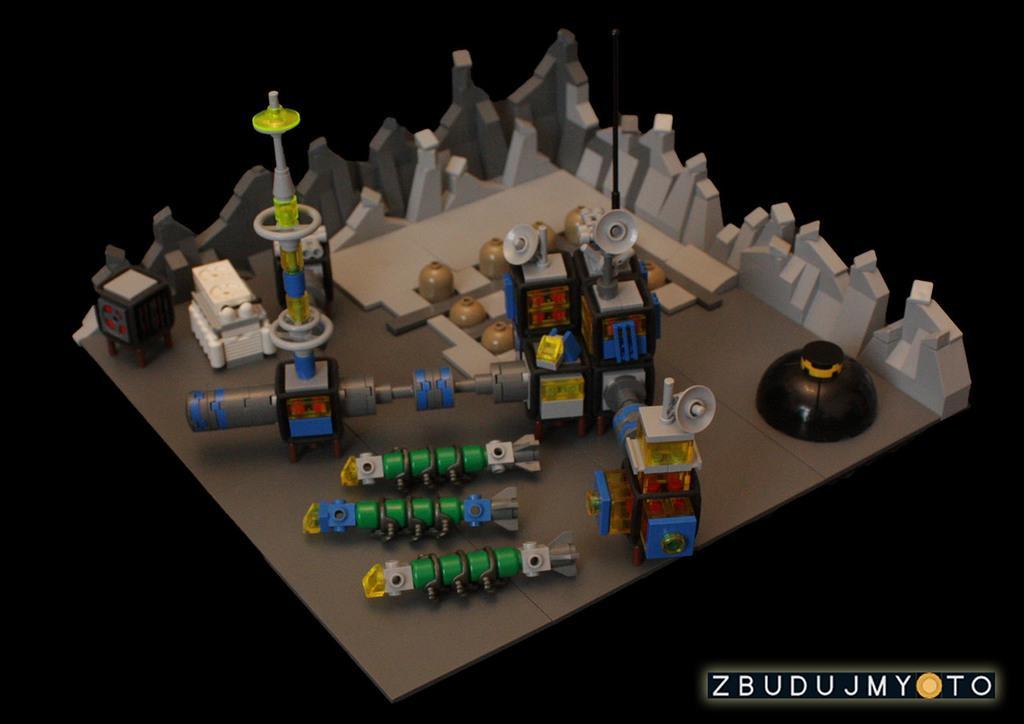In one or two sentences, can you explain what this image depicts? In this image, we can see different kind of toys and in the background we can see the dark. 